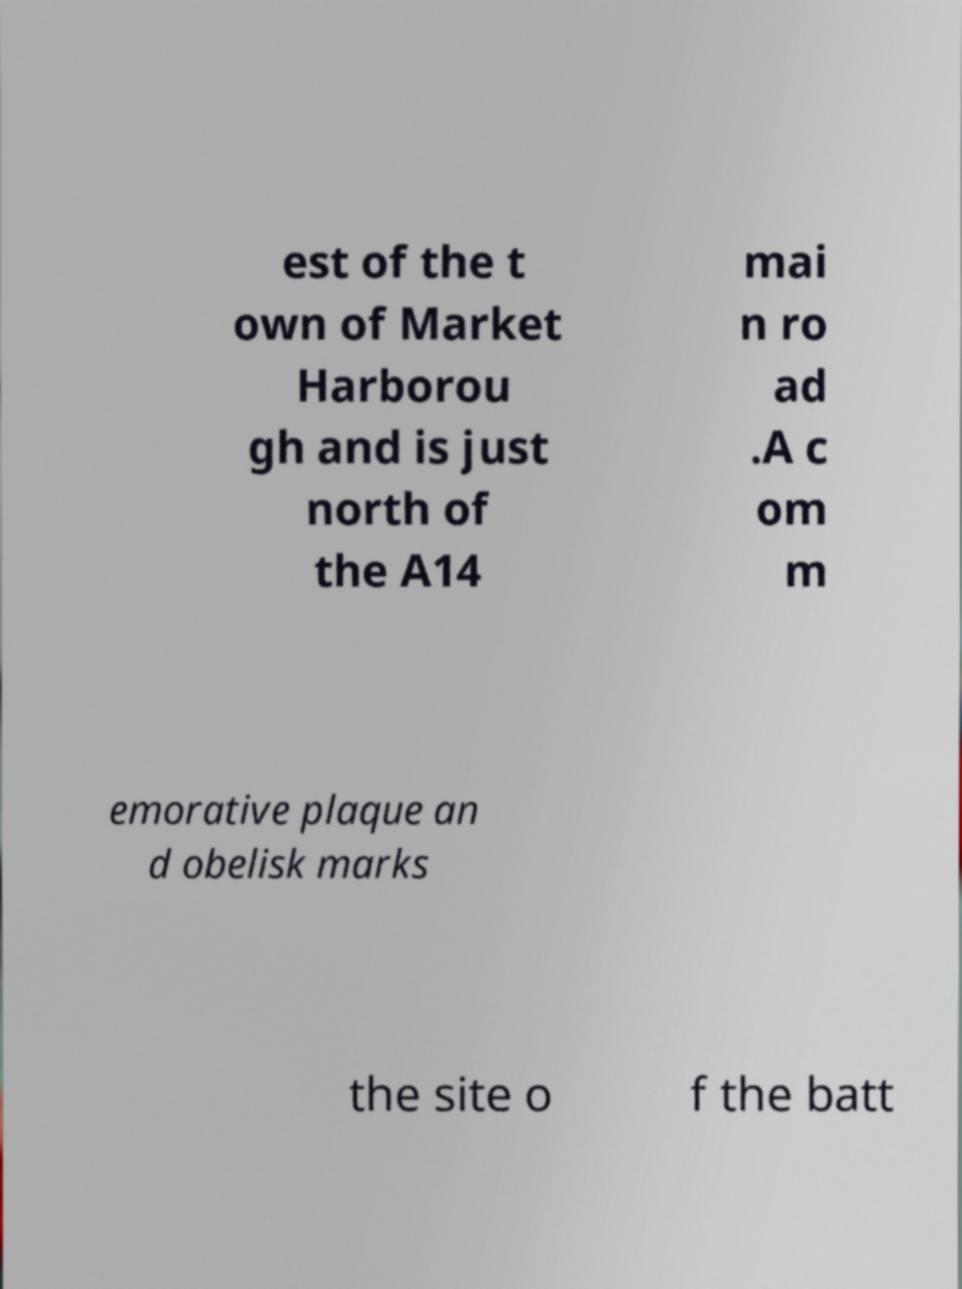Please read and relay the text visible in this image. What does it say? est of the t own of Market Harborou gh and is just north of the A14 mai n ro ad .A c om m emorative plaque an d obelisk marks the site o f the batt 